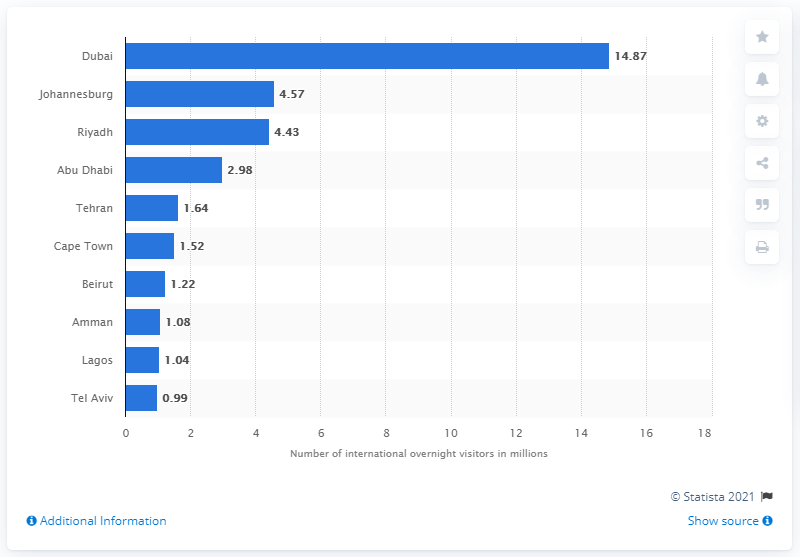Outline some significant characteristics in this image. Dubai was the city with the most international overnight visitors in 2016, with a significant number of tourists arriving to explore the city's diverse attractions. In 2016, Dubai welcomed 14,870 international overnight visitors. 